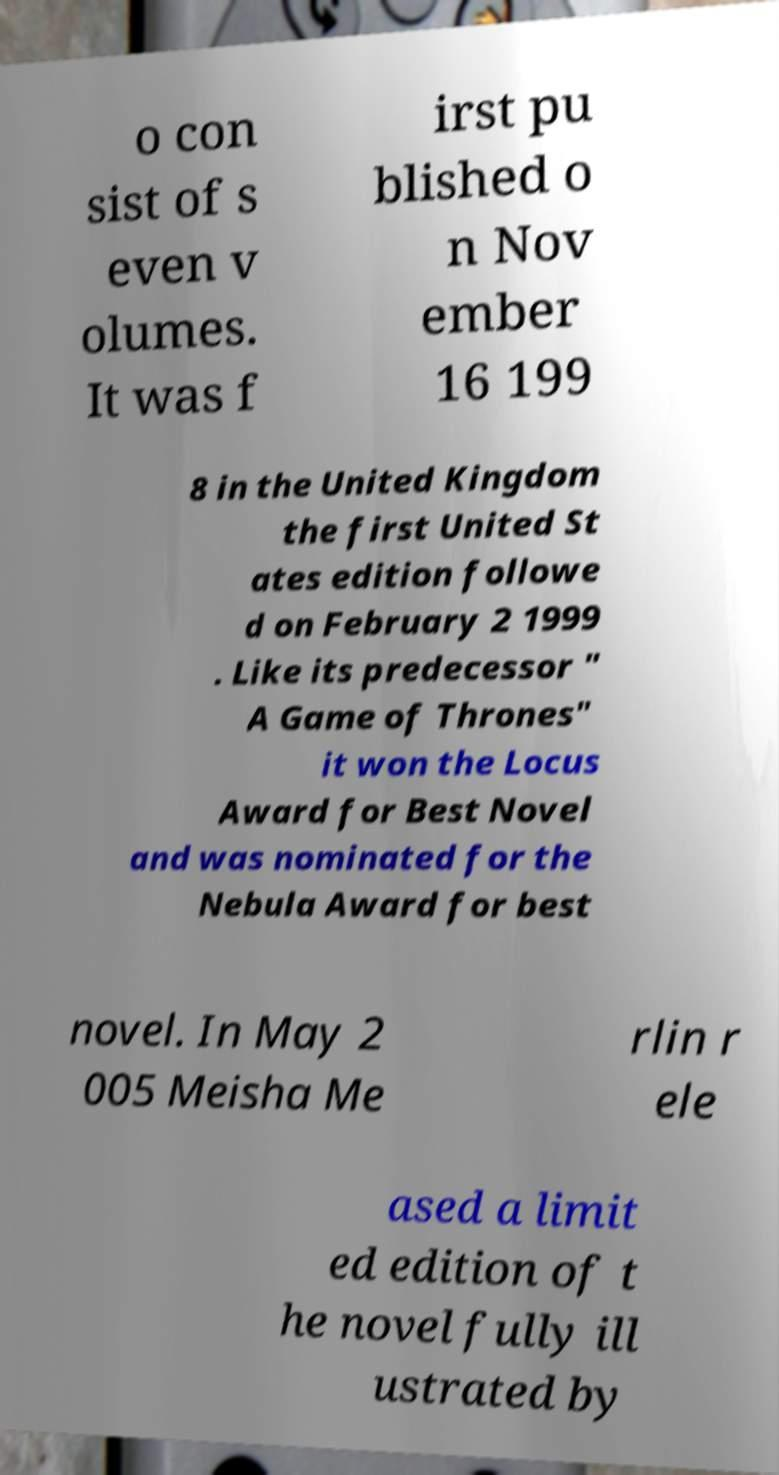Please identify and transcribe the text found in this image. o con sist of s even v olumes. It was f irst pu blished o n Nov ember 16 199 8 in the United Kingdom the first United St ates edition followe d on February 2 1999 . Like its predecessor " A Game of Thrones" it won the Locus Award for Best Novel and was nominated for the Nebula Award for best novel. In May 2 005 Meisha Me rlin r ele ased a limit ed edition of t he novel fully ill ustrated by 